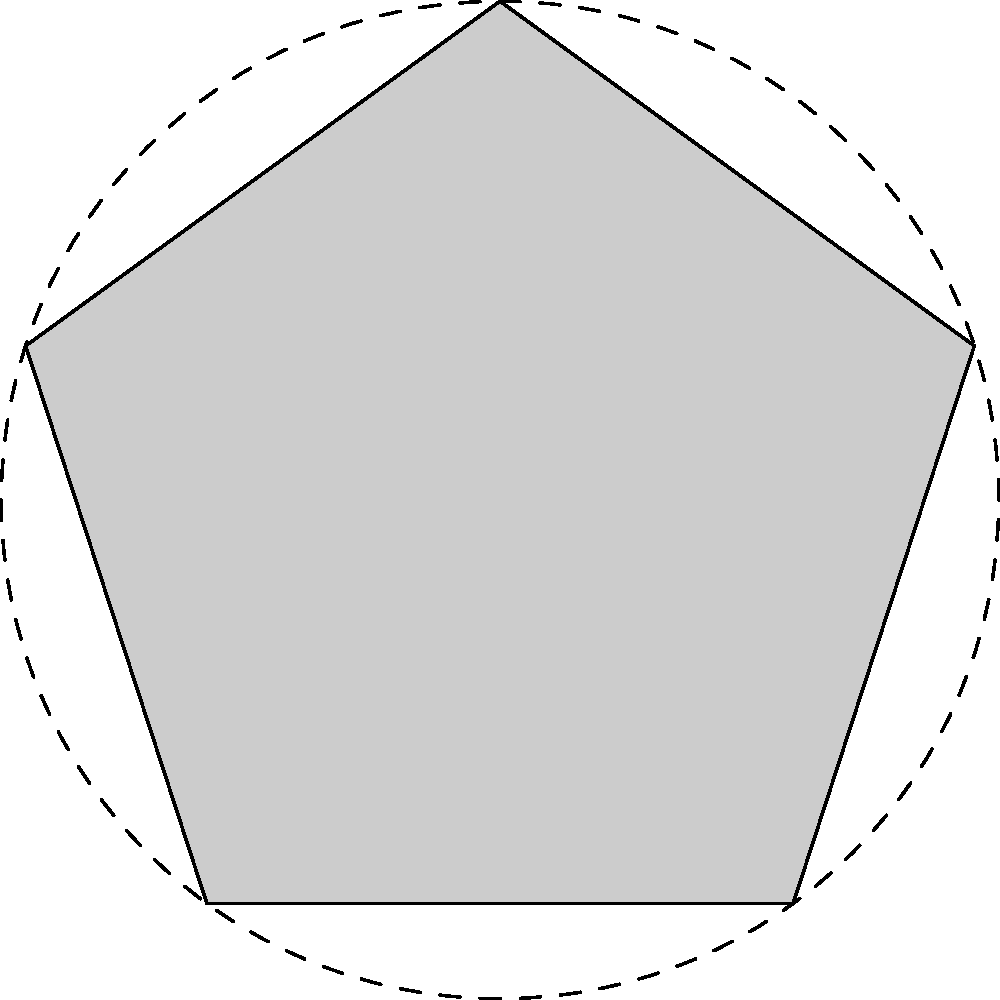In Islamic geometric patterns, the five-pointed star shown above is a common motif. What is the order of rotational symmetry for this star pattern, and how does this relate to the concept of tawhid (the oneness of Allah) in Islamic art? To determine the order of rotational symmetry for this Islamic star pattern, we need to follow these steps:

1. Observe the star pattern carefully. Notice that it consists of a single five-pointed star repeated around a central point.

2. Count the number of times the pattern appears identical as it rotates through a full 360°. In this case, the star pattern repeats 5 times in a full rotation.

3. The order of rotational symmetry is equal to the number of times the pattern repeats in a full rotation. Therefore, the order of rotational symmetry is 5.

Relating this to the concept of tawhid in Islamic art:

1. Tawhid refers to the oneness and unity of Allah, which is a fundamental principle in Islam.

2. The use of geometric patterns with rotational symmetry in Islamic art symbolizes this unity and perfection of Allah's creation.

3. The five-pointed star, with its rotational symmetry of order 5, represents harmony and balance in the universe created by Allah.

4. The repetition of the star pattern around a central point can be seen as a representation of how all creation revolves around the oneness of Allah.

5. The use of geometry and mathematical precision in creating such patterns reflects the order and perfection in Allah's creation, reinforcing the concept of tawhid.

Thus, the rotational symmetry of this star pattern serves as a visual representation of the underlying principles of Islamic faith, particularly the concept of tawhid.
Answer: Order of rotational symmetry: 5. This represents tawhid by symbolizing unity, perfection, and the centrality of Allah in creation through geometric harmony. 